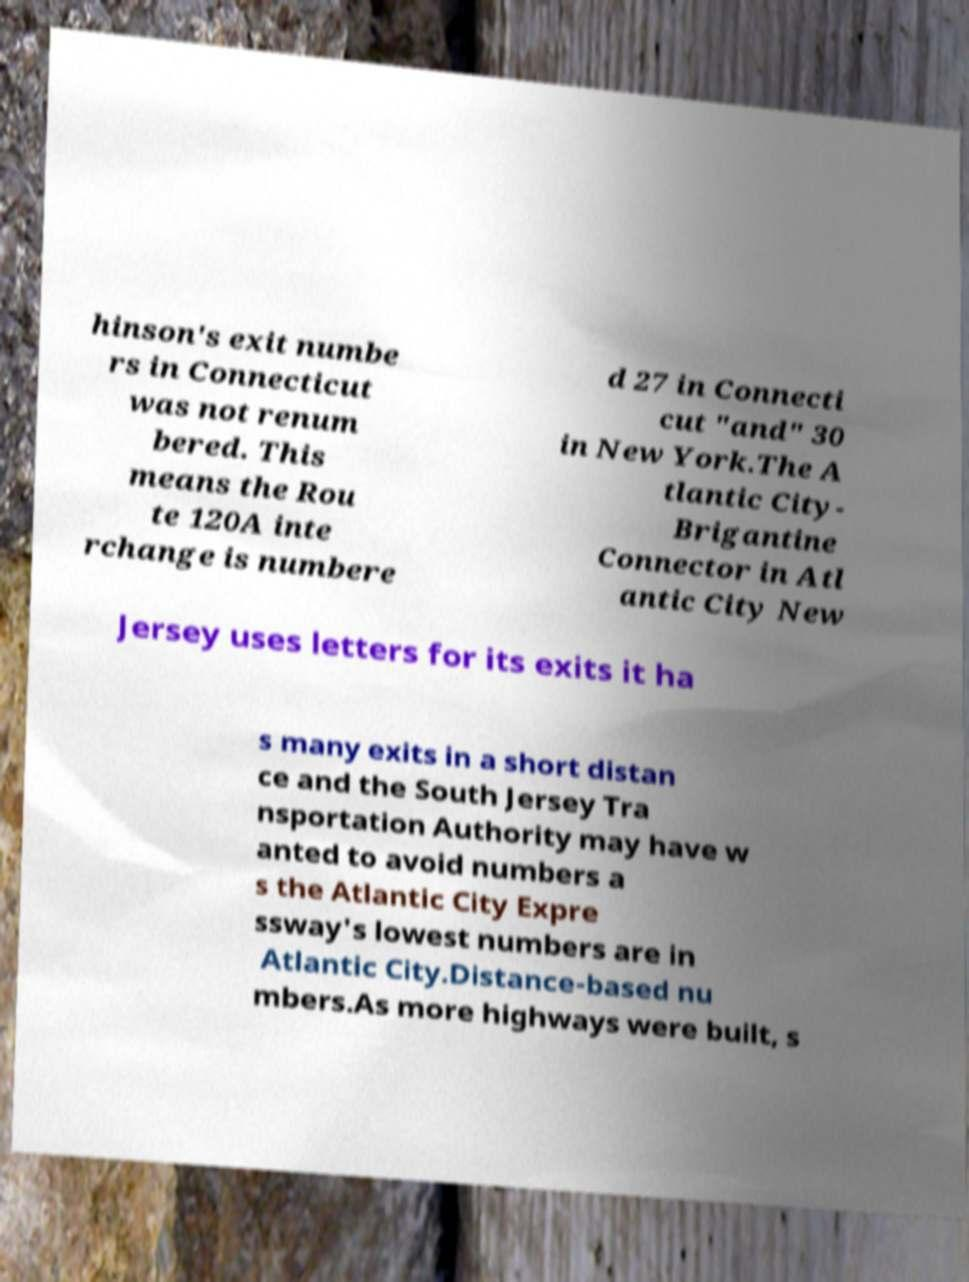Could you assist in decoding the text presented in this image and type it out clearly? hinson's exit numbe rs in Connecticut was not renum bered. This means the Rou te 120A inte rchange is numbere d 27 in Connecti cut "and" 30 in New York.The A tlantic City- Brigantine Connector in Atl antic City New Jersey uses letters for its exits it ha s many exits in a short distan ce and the South Jersey Tra nsportation Authority may have w anted to avoid numbers a s the Atlantic City Expre ssway's lowest numbers are in Atlantic City.Distance-based nu mbers.As more highways were built, s 